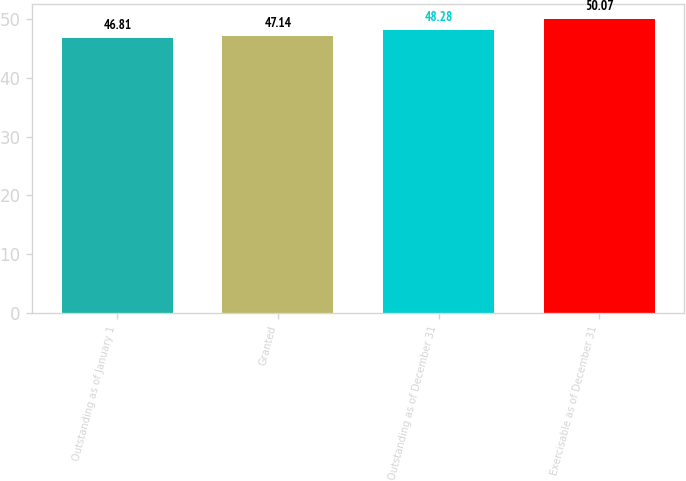Convert chart to OTSL. <chart><loc_0><loc_0><loc_500><loc_500><bar_chart><fcel>Outstanding as of January 1<fcel>Granted<fcel>Outstanding as of December 31<fcel>Exercisable as of December 31<nl><fcel>46.81<fcel>47.14<fcel>48.28<fcel>50.07<nl></chart> 